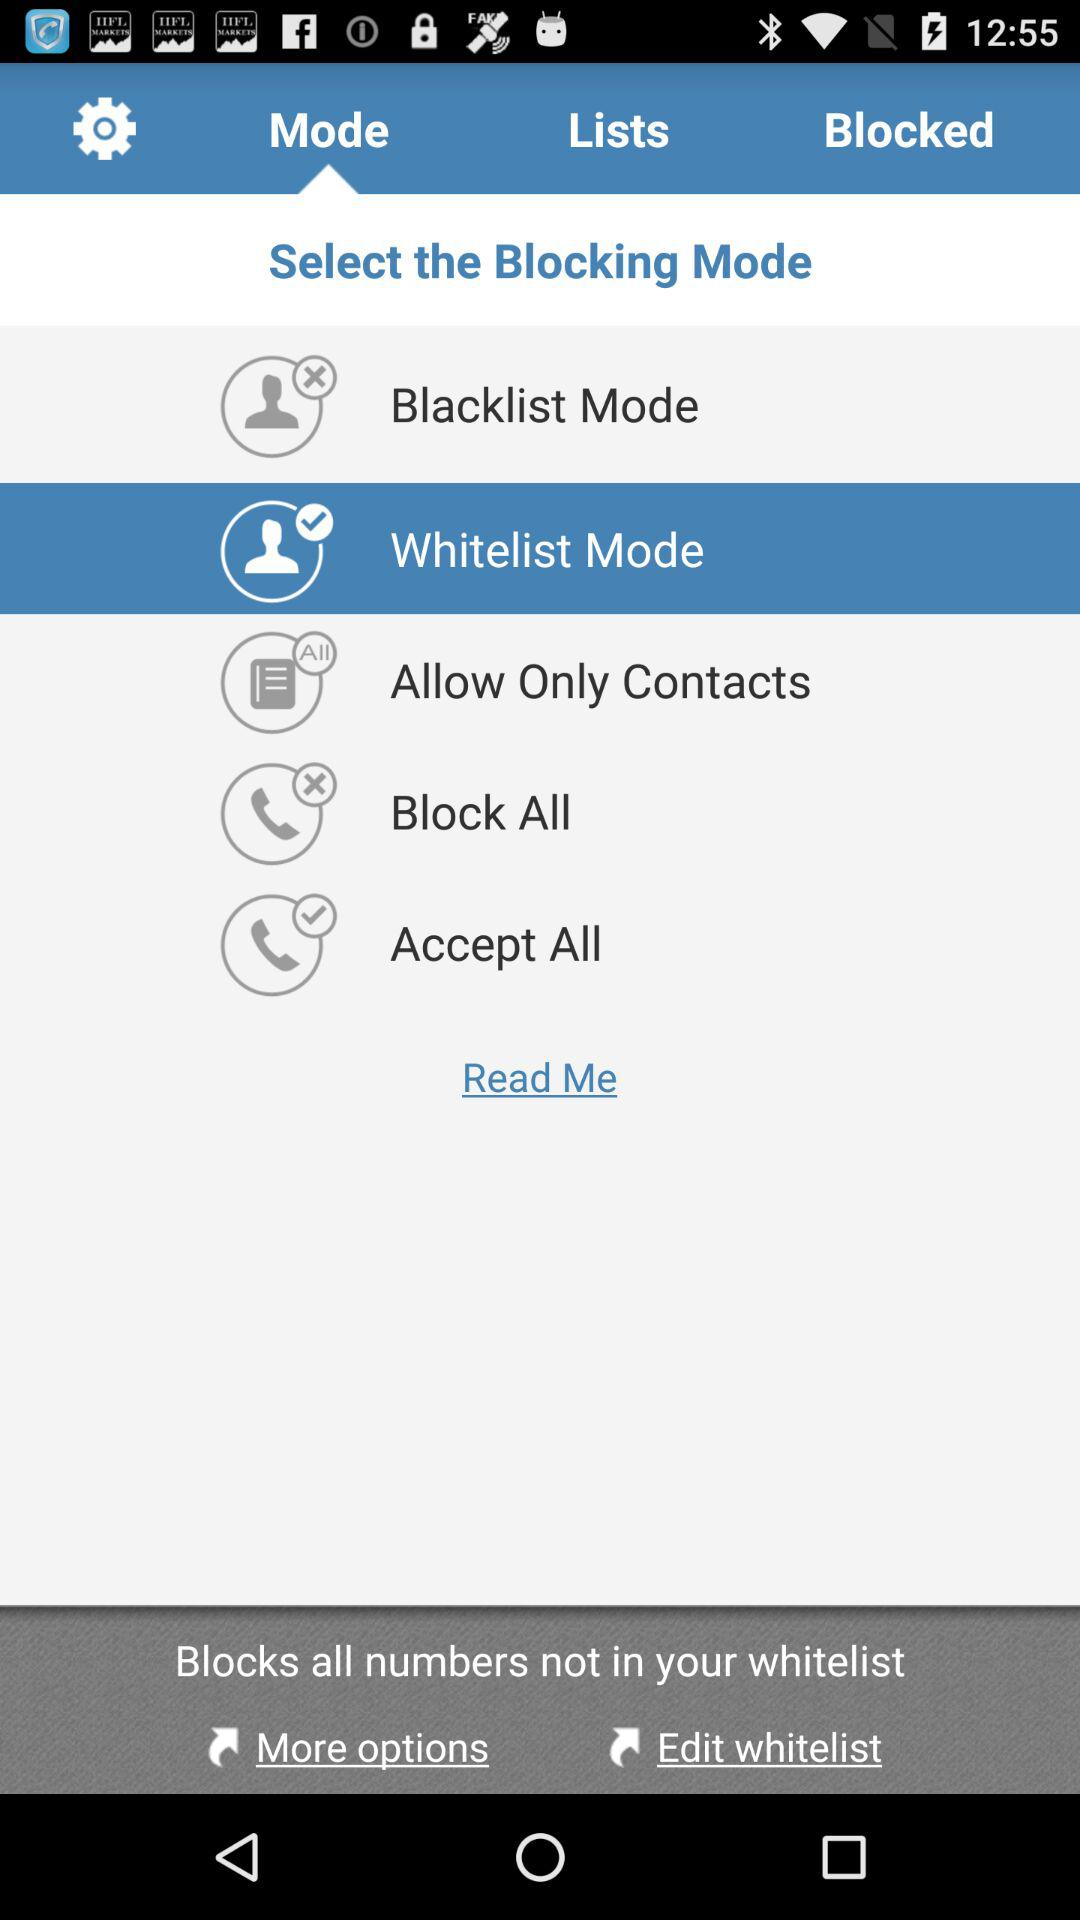Which are the different blocking modes? The different blocking modes are "Blacklist", "Whitelist", "Allow Only Contacts", "Block All" and "Accept All". 